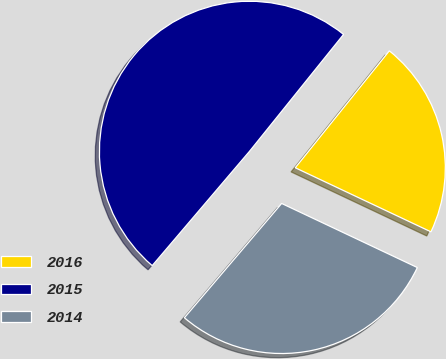<chart> <loc_0><loc_0><loc_500><loc_500><pie_chart><fcel>2016<fcel>2015<fcel>2014<nl><fcel>21.24%<fcel>49.56%<fcel>29.2%<nl></chart> 